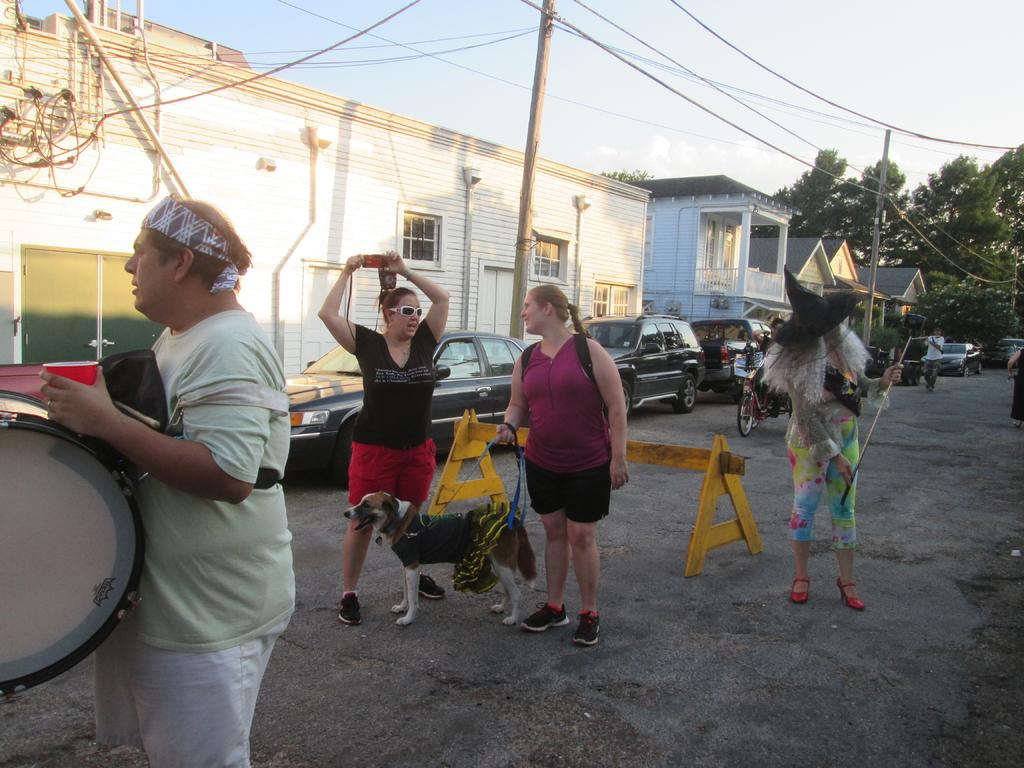What types of people are in the image? There are men and women in the image. What activity might be taking place in the image? The presence of a musical instrument suggests that there might be a musical performance happening. What other living creature is in the image? There is a dog in the image. What can be seen in the background of the image? There are vehicles, buildings, and trees in the background of the image. What type of volcano can be seen erupting in the image? There is no volcano present in the image. How many pets are visible in the image? There is only one living creature other than humans in the image, which is a dog. Therefore, there is only one pet visible, and it is a dog. 